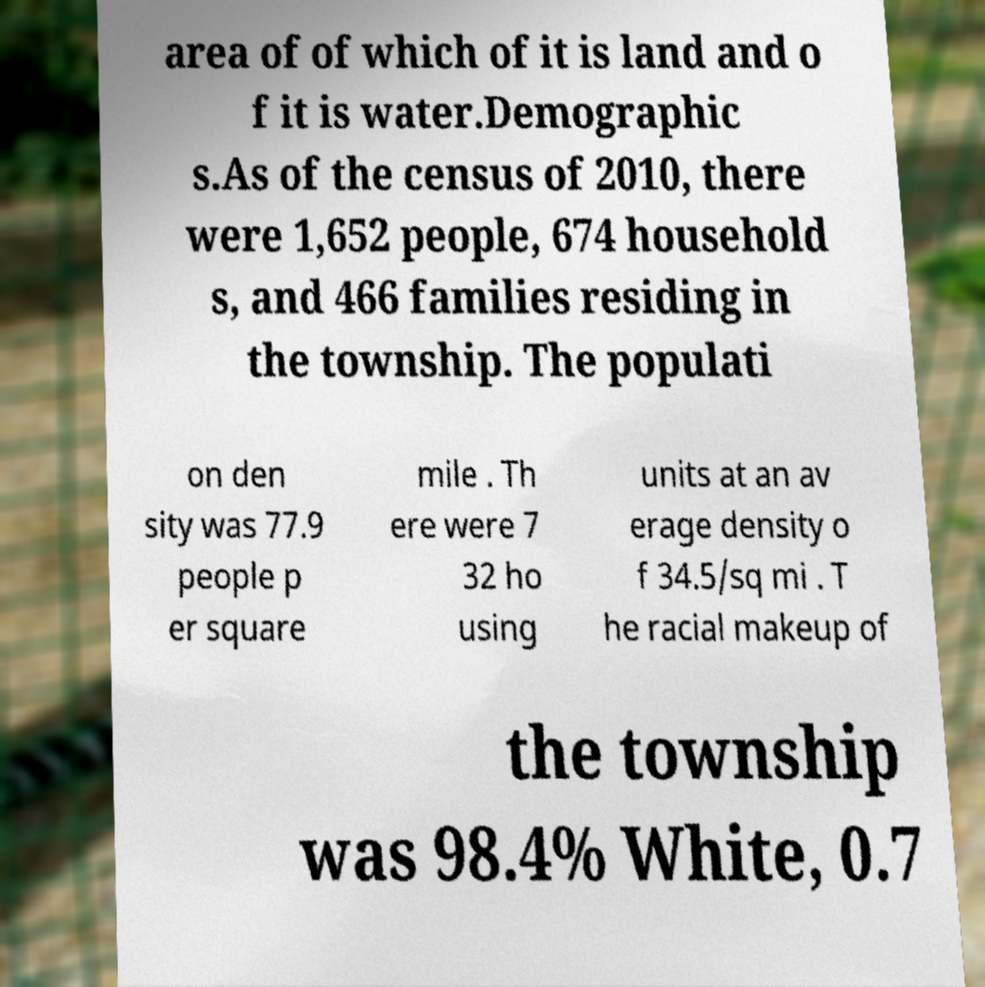There's text embedded in this image that I need extracted. Can you transcribe it verbatim? area of of which of it is land and o f it is water.Demographic s.As of the census of 2010, there were 1,652 people, 674 household s, and 466 families residing in the township. The populati on den sity was 77.9 people p er square mile . Th ere were 7 32 ho using units at an av erage density o f 34.5/sq mi . T he racial makeup of the township was 98.4% White, 0.7 